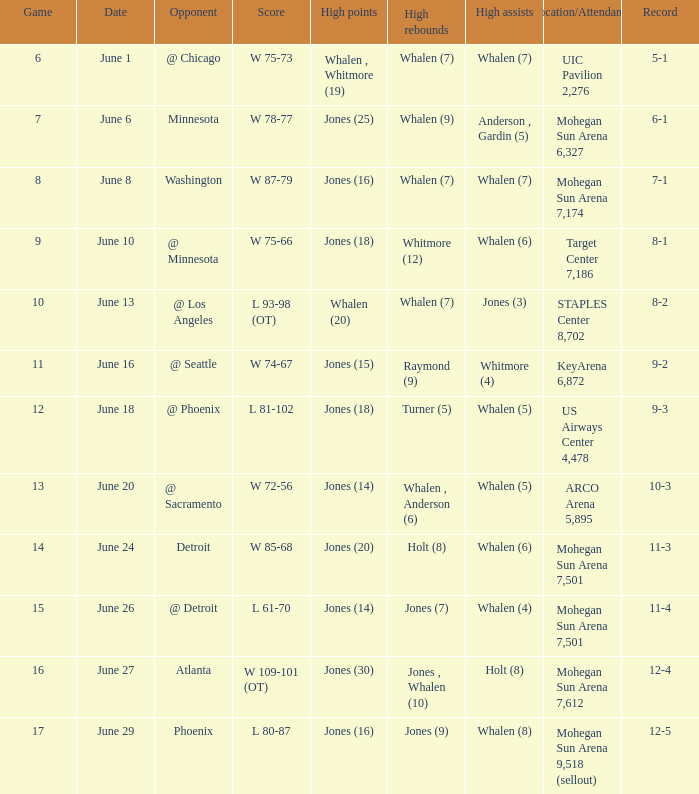Could you parse the entire table as a dict? {'header': ['Game', 'Date', 'Opponent', 'Score', 'High points', 'High rebounds', 'High assists', 'Location/Attendance', 'Record'], 'rows': [['6', 'June 1', '@ Chicago', 'W 75-73', 'Whalen , Whitmore (19)', 'Whalen (7)', 'Whalen (7)', 'UIC Pavilion 2,276', '5-1'], ['7', 'June 6', 'Minnesota', 'W 78-77', 'Jones (25)', 'Whalen (9)', 'Anderson , Gardin (5)', 'Mohegan Sun Arena 6,327', '6-1'], ['8', 'June 8', 'Washington', 'W 87-79', 'Jones (16)', 'Whalen (7)', 'Whalen (7)', 'Mohegan Sun Arena 7,174', '7-1'], ['9', 'June 10', '@ Minnesota', 'W 75-66', 'Jones (18)', 'Whitmore (12)', 'Whalen (6)', 'Target Center 7,186', '8-1'], ['10', 'June 13', '@ Los Angeles', 'L 93-98 (OT)', 'Whalen (20)', 'Whalen (7)', 'Jones (3)', 'STAPLES Center 8,702', '8-2'], ['11', 'June 16', '@ Seattle', 'W 74-67', 'Jones (15)', 'Raymond (9)', 'Whitmore (4)', 'KeyArena 6,872', '9-2'], ['12', 'June 18', '@ Phoenix', 'L 81-102', 'Jones (18)', 'Turner (5)', 'Whalen (5)', 'US Airways Center 4,478', '9-3'], ['13', 'June 20', '@ Sacramento', 'W 72-56', 'Jones (14)', 'Whalen , Anderson (6)', 'Whalen (5)', 'ARCO Arena 5,895', '10-3'], ['14', 'June 24', 'Detroit', 'W 85-68', 'Jones (20)', 'Holt (8)', 'Whalen (6)', 'Mohegan Sun Arena 7,501', '11-3'], ['15', 'June 26', '@ Detroit', 'L 61-70', 'Jones (14)', 'Jones (7)', 'Whalen (4)', 'Mohegan Sun Arena 7,501', '11-4'], ['16', 'June 27', 'Atlanta', 'W 109-101 (OT)', 'Jones (30)', 'Jones , Whalen (10)', 'Holt (8)', 'Mohegan Sun Arena 7,612', '12-4'], ['17', 'June 29', 'Phoenix', 'L 80-87', 'Jones (16)', 'Jones (9)', 'Whalen (8)', 'Mohegan Sun Arena 9,518 (sellout)', '12-5']]} What is the contest on june 29? 17.0. 